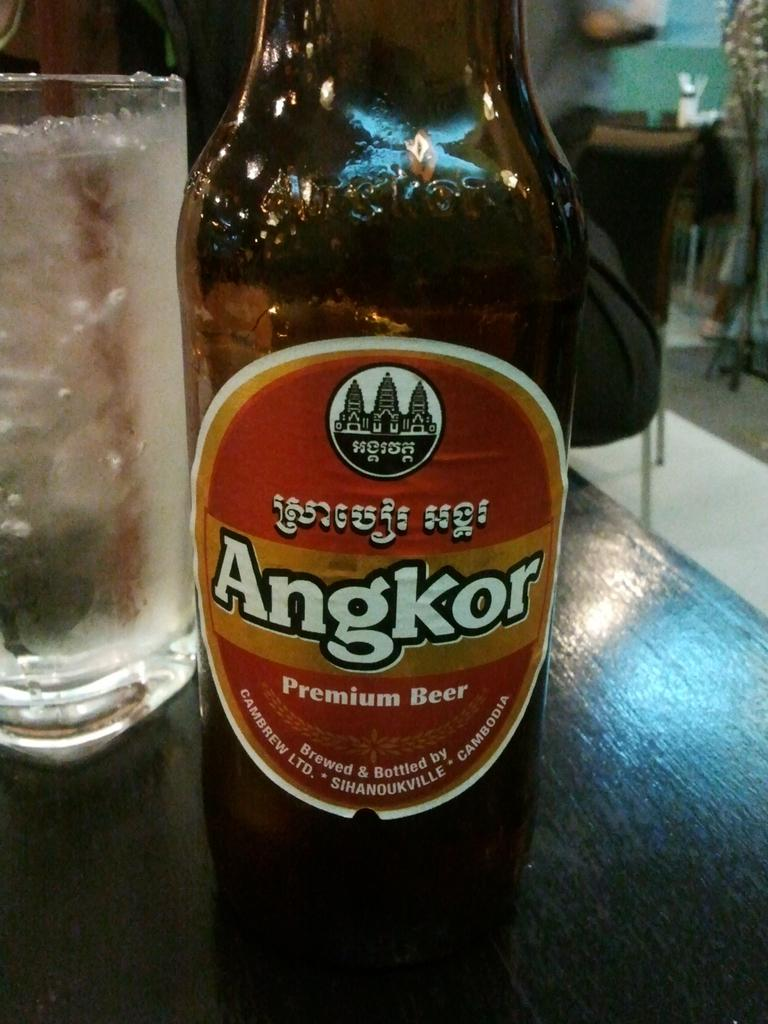<image>
Render a clear and concise summary of the photo. A bottle of Angkor Premium Beer sits on a wooden table 